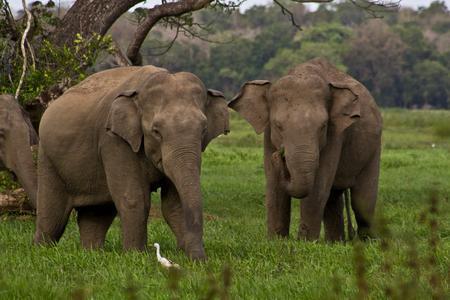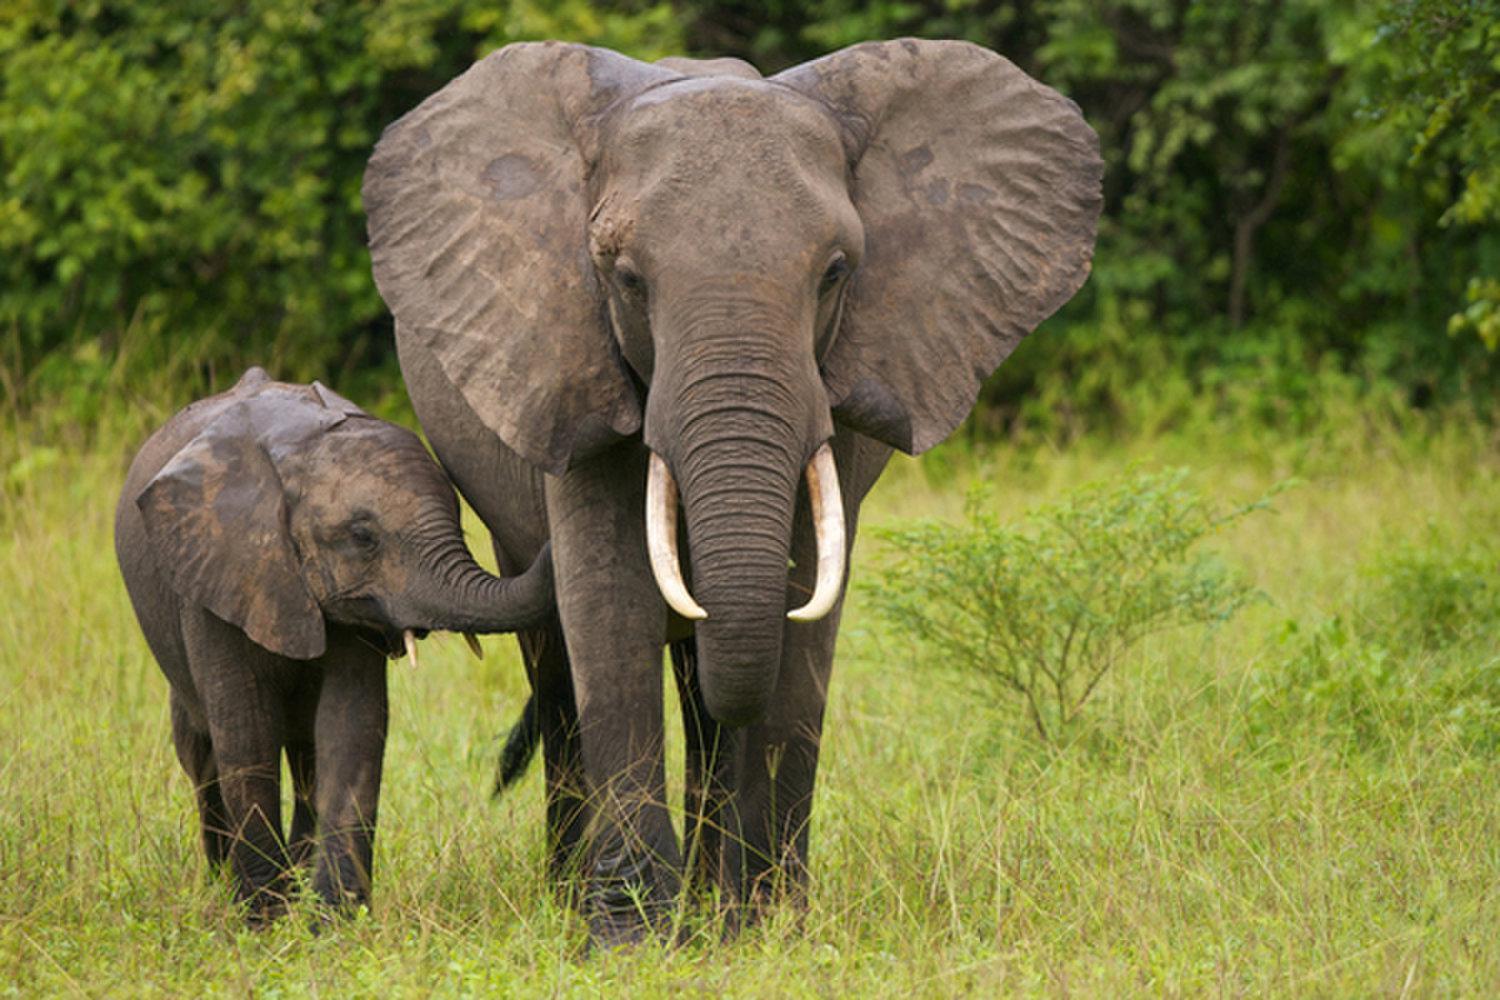The first image is the image on the left, the second image is the image on the right. Evaluate the accuracy of this statement regarding the images: "An image shows an elephant with tusks facing the camera.". Is it true? Answer yes or no. Yes. 